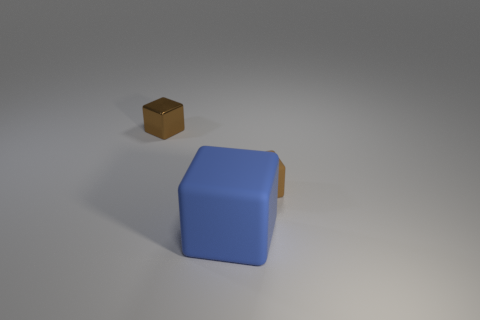Add 3 big blue matte cubes. How many objects exist? 6 Add 3 big gray objects. How many big gray objects exist? 3 Subtract 0 blue spheres. How many objects are left? 3 Subtract all gray matte objects. Subtract all brown matte cubes. How many objects are left? 2 Add 3 tiny brown blocks. How many tiny brown blocks are left? 5 